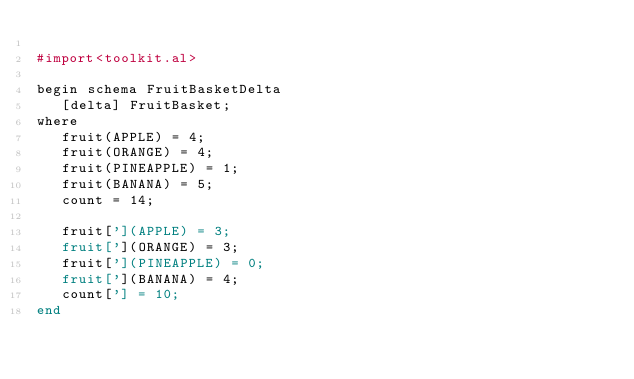<code> <loc_0><loc_0><loc_500><loc_500><_Perl_>
#import<toolkit.al>

begin schema FruitBasketDelta
   [delta] FruitBasket;
where
   fruit(APPLE) = 4;
   fruit(ORANGE) = 4;
   fruit(PINEAPPLE) = 1;
   fruit(BANANA) = 5;
   count = 14;

   fruit['](APPLE) = 3;
   fruit['](ORANGE) = 3;
   fruit['](PINEAPPLE) = 0;
   fruit['](BANANA) = 4;
   count['] = 10;
end
</code> 